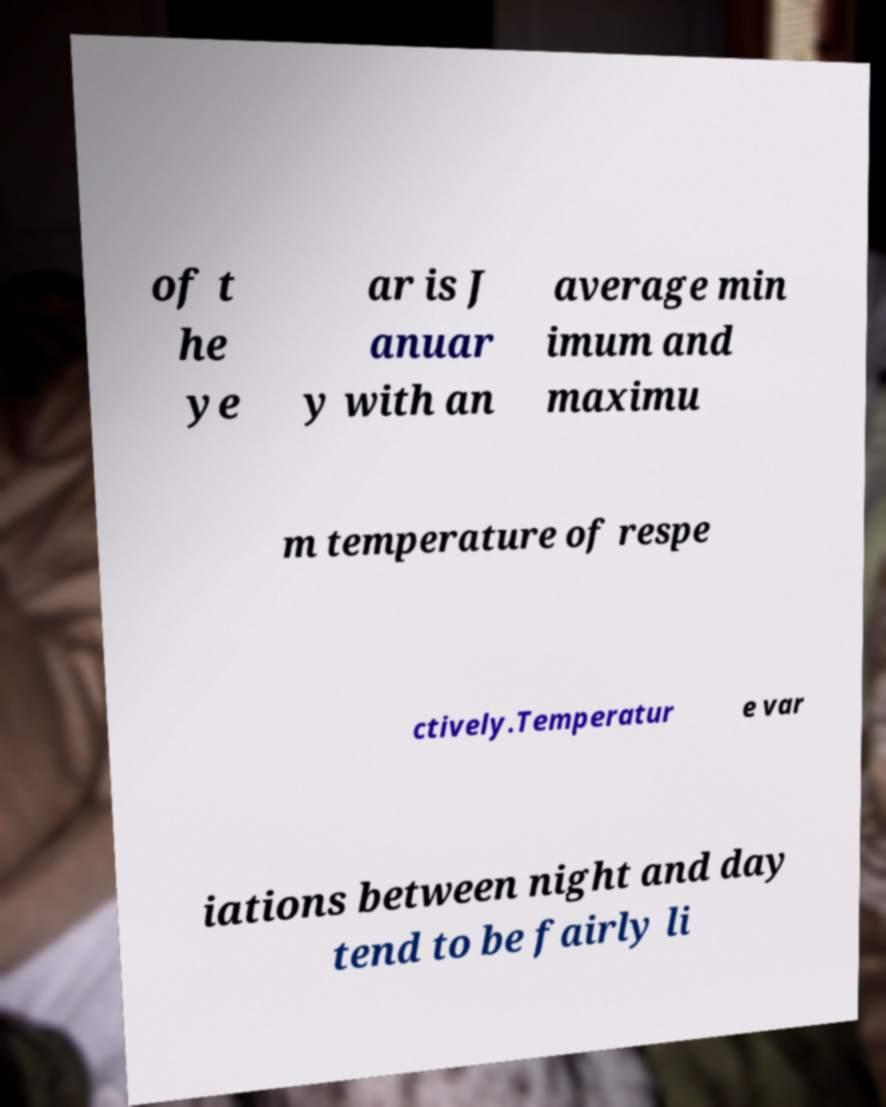For documentation purposes, I need the text within this image transcribed. Could you provide that? of t he ye ar is J anuar y with an average min imum and maximu m temperature of respe ctively.Temperatur e var iations between night and day tend to be fairly li 